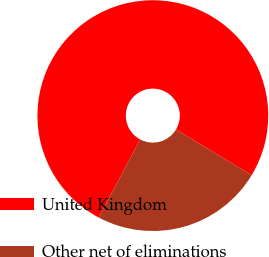<chart> <loc_0><loc_0><loc_500><loc_500><pie_chart><fcel>United Kingdom<fcel>Other net of eliminations<nl><fcel>75.86%<fcel>24.14%<nl></chart> 